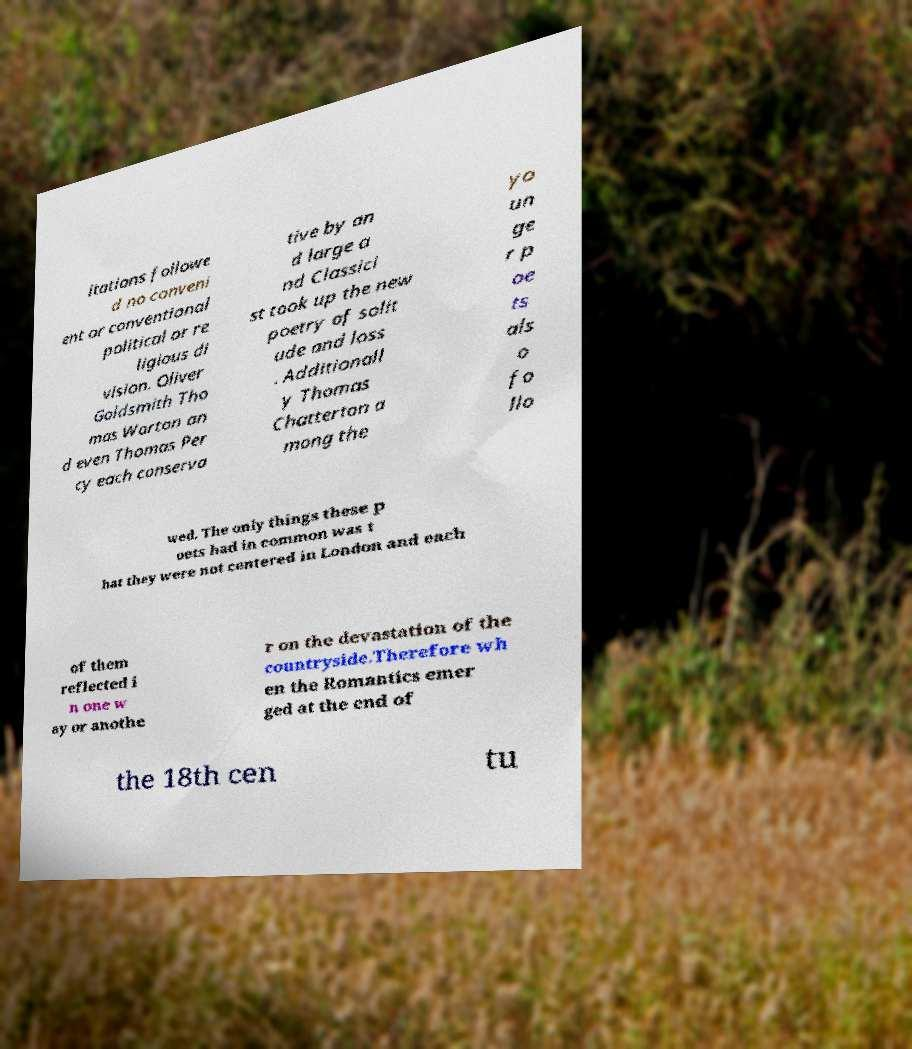For documentation purposes, I need the text within this image transcribed. Could you provide that? itations followe d no conveni ent or conventional political or re ligious di vision. Oliver Goldsmith Tho mas Warton an d even Thomas Per cy each conserva tive by an d large a nd Classici st took up the new poetry of solit ude and loss . Additionall y Thomas Chatterton a mong the yo un ge r p oe ts als o fo llo wed. The only things these p oets had in common was t hat they were not centered in London and each of them reflected i n one w ay or anothe r on the devastation of the countryside.Therefore wh en the Romantics emer ged at the end of the 18th cen tu 